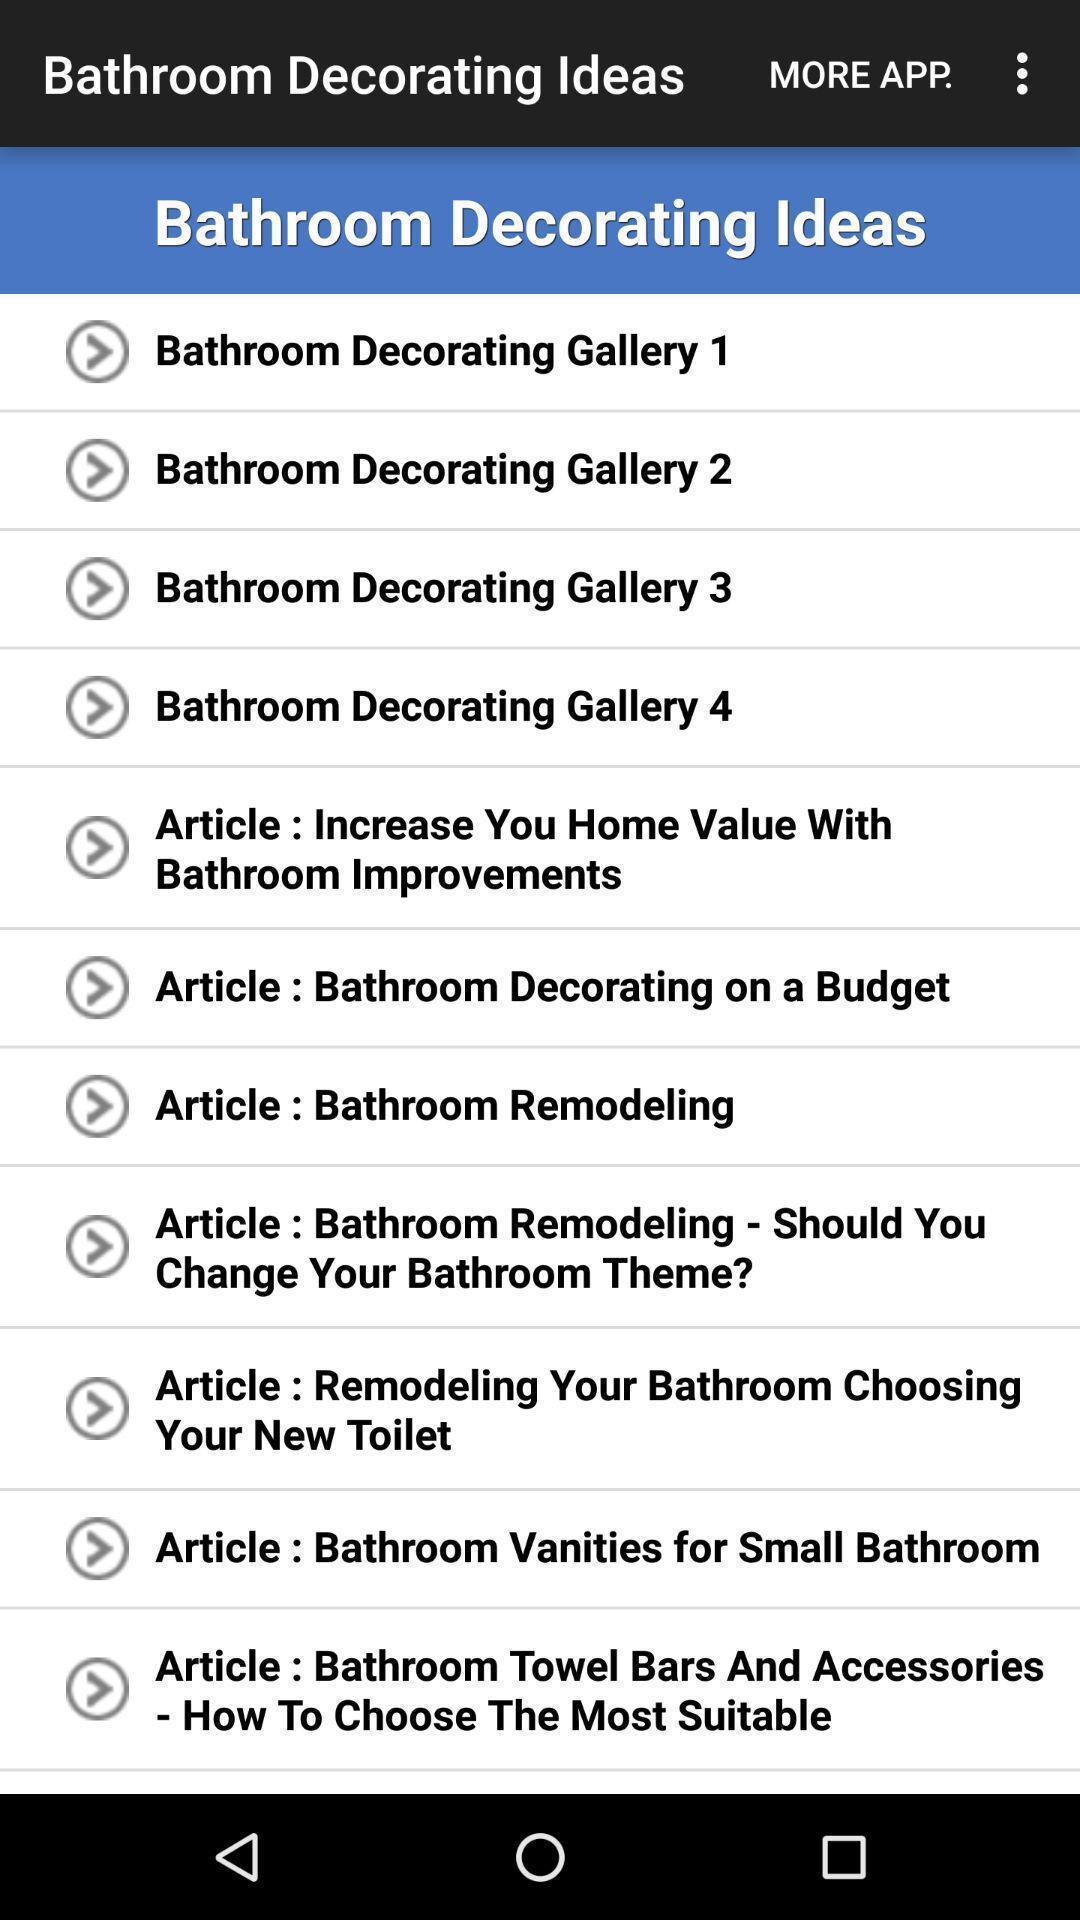Provide a textual representation of this image. Screen displaying the list of bathroom decorating ideas. 